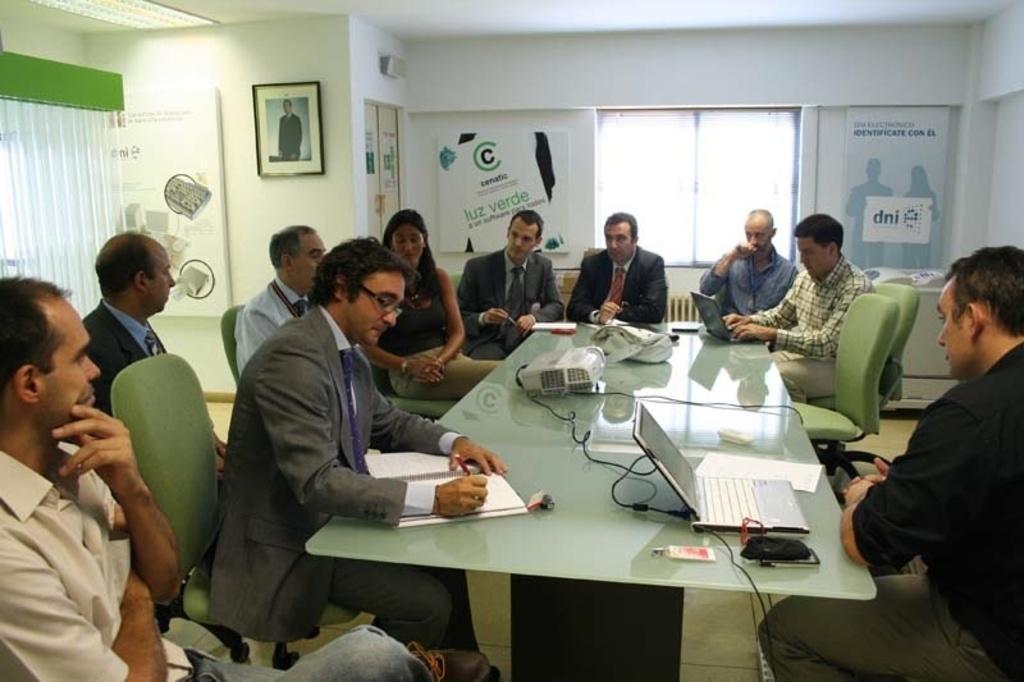In one or two sentences, can you explain what this image depicts? In this picture there are group of people sitting around a table. On the table there is a laptop, a book and a wire. In the background there is a wall, window, frame and a photograph. 